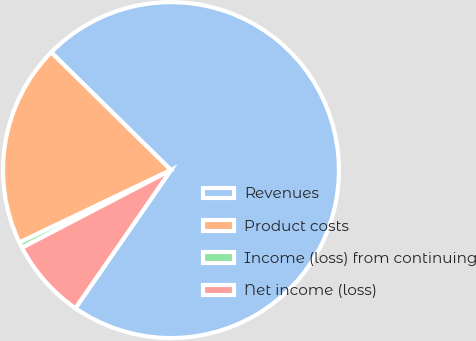Convert chart to OTSL. <chart><loc_0><loc_0><loc_500><loc_500><pie_chart><fcel>Revenues<fcel>Product costs<fcel>Income (loss) from continuing<fcel>Net income (loss)<nl><fcel>72.27%<fcel>19.46%<fcel>0.55%<fcel>7.72%<nl></chart> 